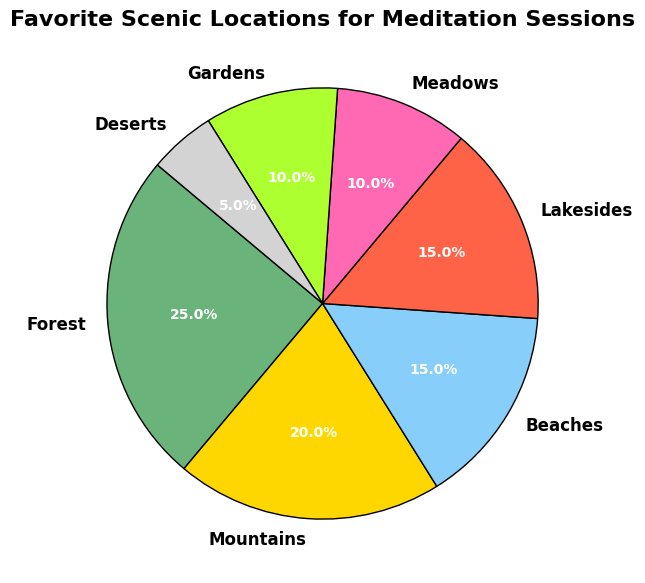What percentage of people prefer forests for meditation sessions? The pie chart shows that forests are favored by a quarter of respondents. Therefore, the percentage of people who prefer forests is 25%.
Answer: 25% Which type of scenic location has the lowest preference among respondents? Looking at the pie chart, deserts have the smallest wedge, indicating the lowest preference at 5%.
Answer: Deserts Is the preference for beaches higher, lower, or equal to the preference for lakesides? The pie chart displays that both beaches and lakesides have a wedge labeled 15%. Therefore, their preferences are equal.
Answer: Equal What's the combined percentage of people who prefer mountains and meadows? From the pie chart, the percentages for mountains and meadows are 20% and 10% respectively. Summing these percentages gives 20% + 10% = 30%.
Answer: 30% What is the color used to represent gardens in the pie chart? The wedge representing gardens in the pie chart is colored light green.
Answer: Light green How many distinct scenic location types are represented on the pie chart? Counting the labels on the pie chart reveals that there are seven distinct scenic locations indicated: Forest, Mountains, Beaches, Lakesides, Meadows, Gardens, and Deserts.
Answer: Seven Which location type has a preference percentage that is double that of deserts? The pie chart shows that deserts have a preference percentage of 5%. The wedge that has double this percentage (10%) represents gardens and meadows. Therefore, both gardens and meadows have double the preference of deserts.
Answer: Gardens, Meadows Compare the preference for forests with the sum of preferences for gardens and deserts. The preference for forests is 25%. Adding the preferences for gardens and deserts, we get 10% + 5% = 15%. Since 25% is greater than 15%, the preference for forests is higher.
Answer: Higher What is the difference in preference percentage between beaches and forests? The pie chart shows 15% for beaches and 25% for forests. The difference is 25% - 15% = 10%.
Answer: 10% If you were to organize a meditation session, which location type would appeal to the largest group of people? According to the pie chart, forests have the highest wedge at 25%, indicating they appeal to the largest group of people.
Answer: Forests 